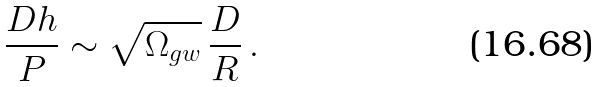<formula> <loc_0><loc_0><loc_500><loc_500>\frac { D h } { P } \sim \sqrt { \Omega _ { g w } } \, \frac { D } { R } \, .</formula> 